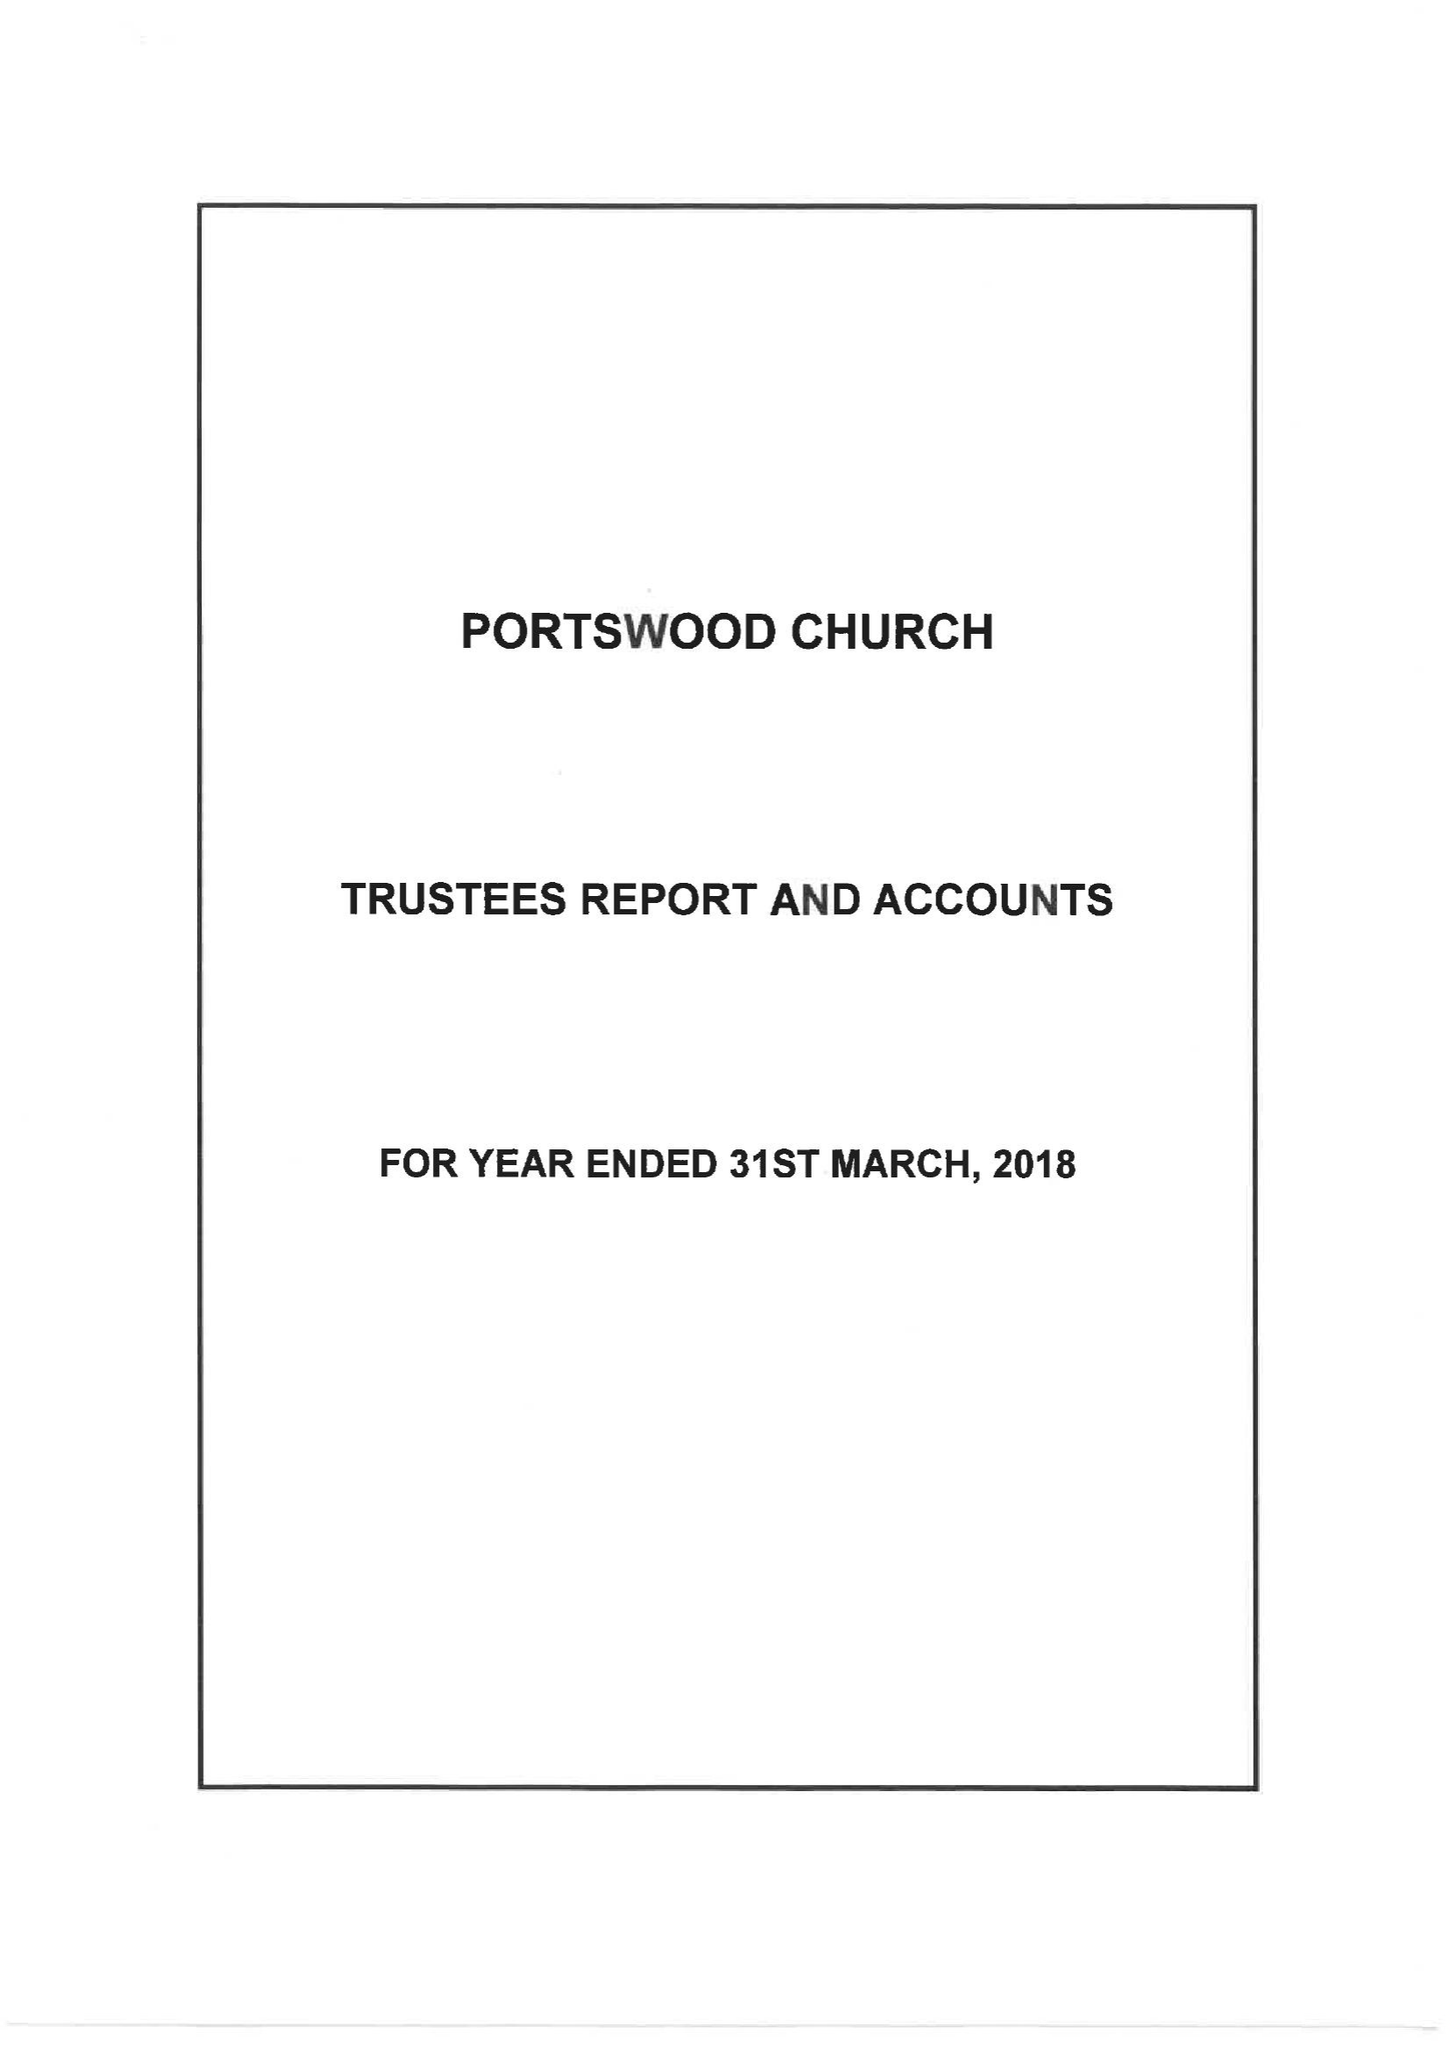What is the value for the income_annually_in_british_pounds?
Answer the question using a single word or phrase. 217520.00 